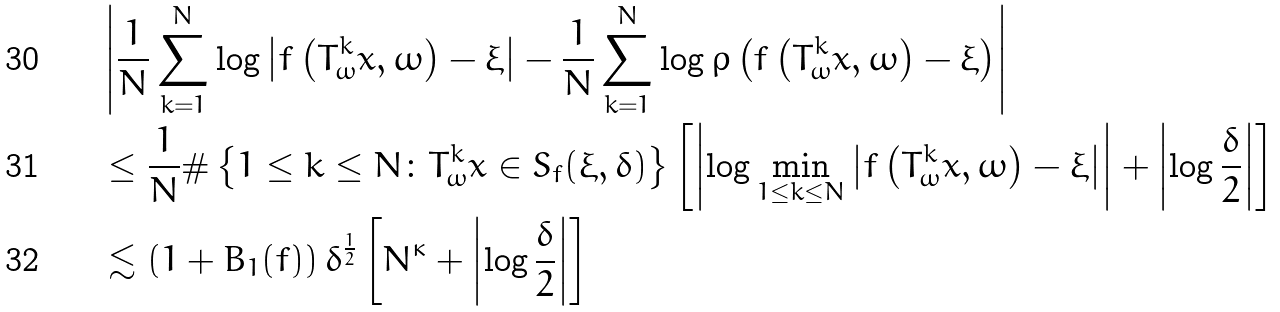<formula> <loc_0><loc_0><loc_500><loc_500>& \left | \frac { 1 } { N } \sum _ { k = 1 } ^ { N } \log \left | f \left ( T _ { \omega } ^ { k } x , \omega \right ) - \xi \right | - \frac { 1 } { N } \sum _ { k = 1 } ^ { N } \log \rho \left ( f \left ( T _ { \omega } ^ { k } x , \omega \right ) - \xi \right ) \right | \\ & \leq \frac { 1 } { N } \# \left \{ 1 \leq k \leq N \colon T _ { \omega } ^ { k } x \in S _ { f } ( \xi , \delta ) \right \} \left [ \left | \log \min _ { 1 \leq k \leq N } \left | f \left ( T _ { \omega } ^ { k } x , \omega \right ) - \xi \right | \right | + \left | \log \frac { \delta } { 2 } \right | \right ] \\ & \lesssim \left ( 1 + B _ { 1 } ( f ) \right ) \delta ^ { \frac { 1 } { 2 } } \left [ N ^ { \kappa } + \left | \log \frac { \delta } { 2 } \right | \right ]</formula> 